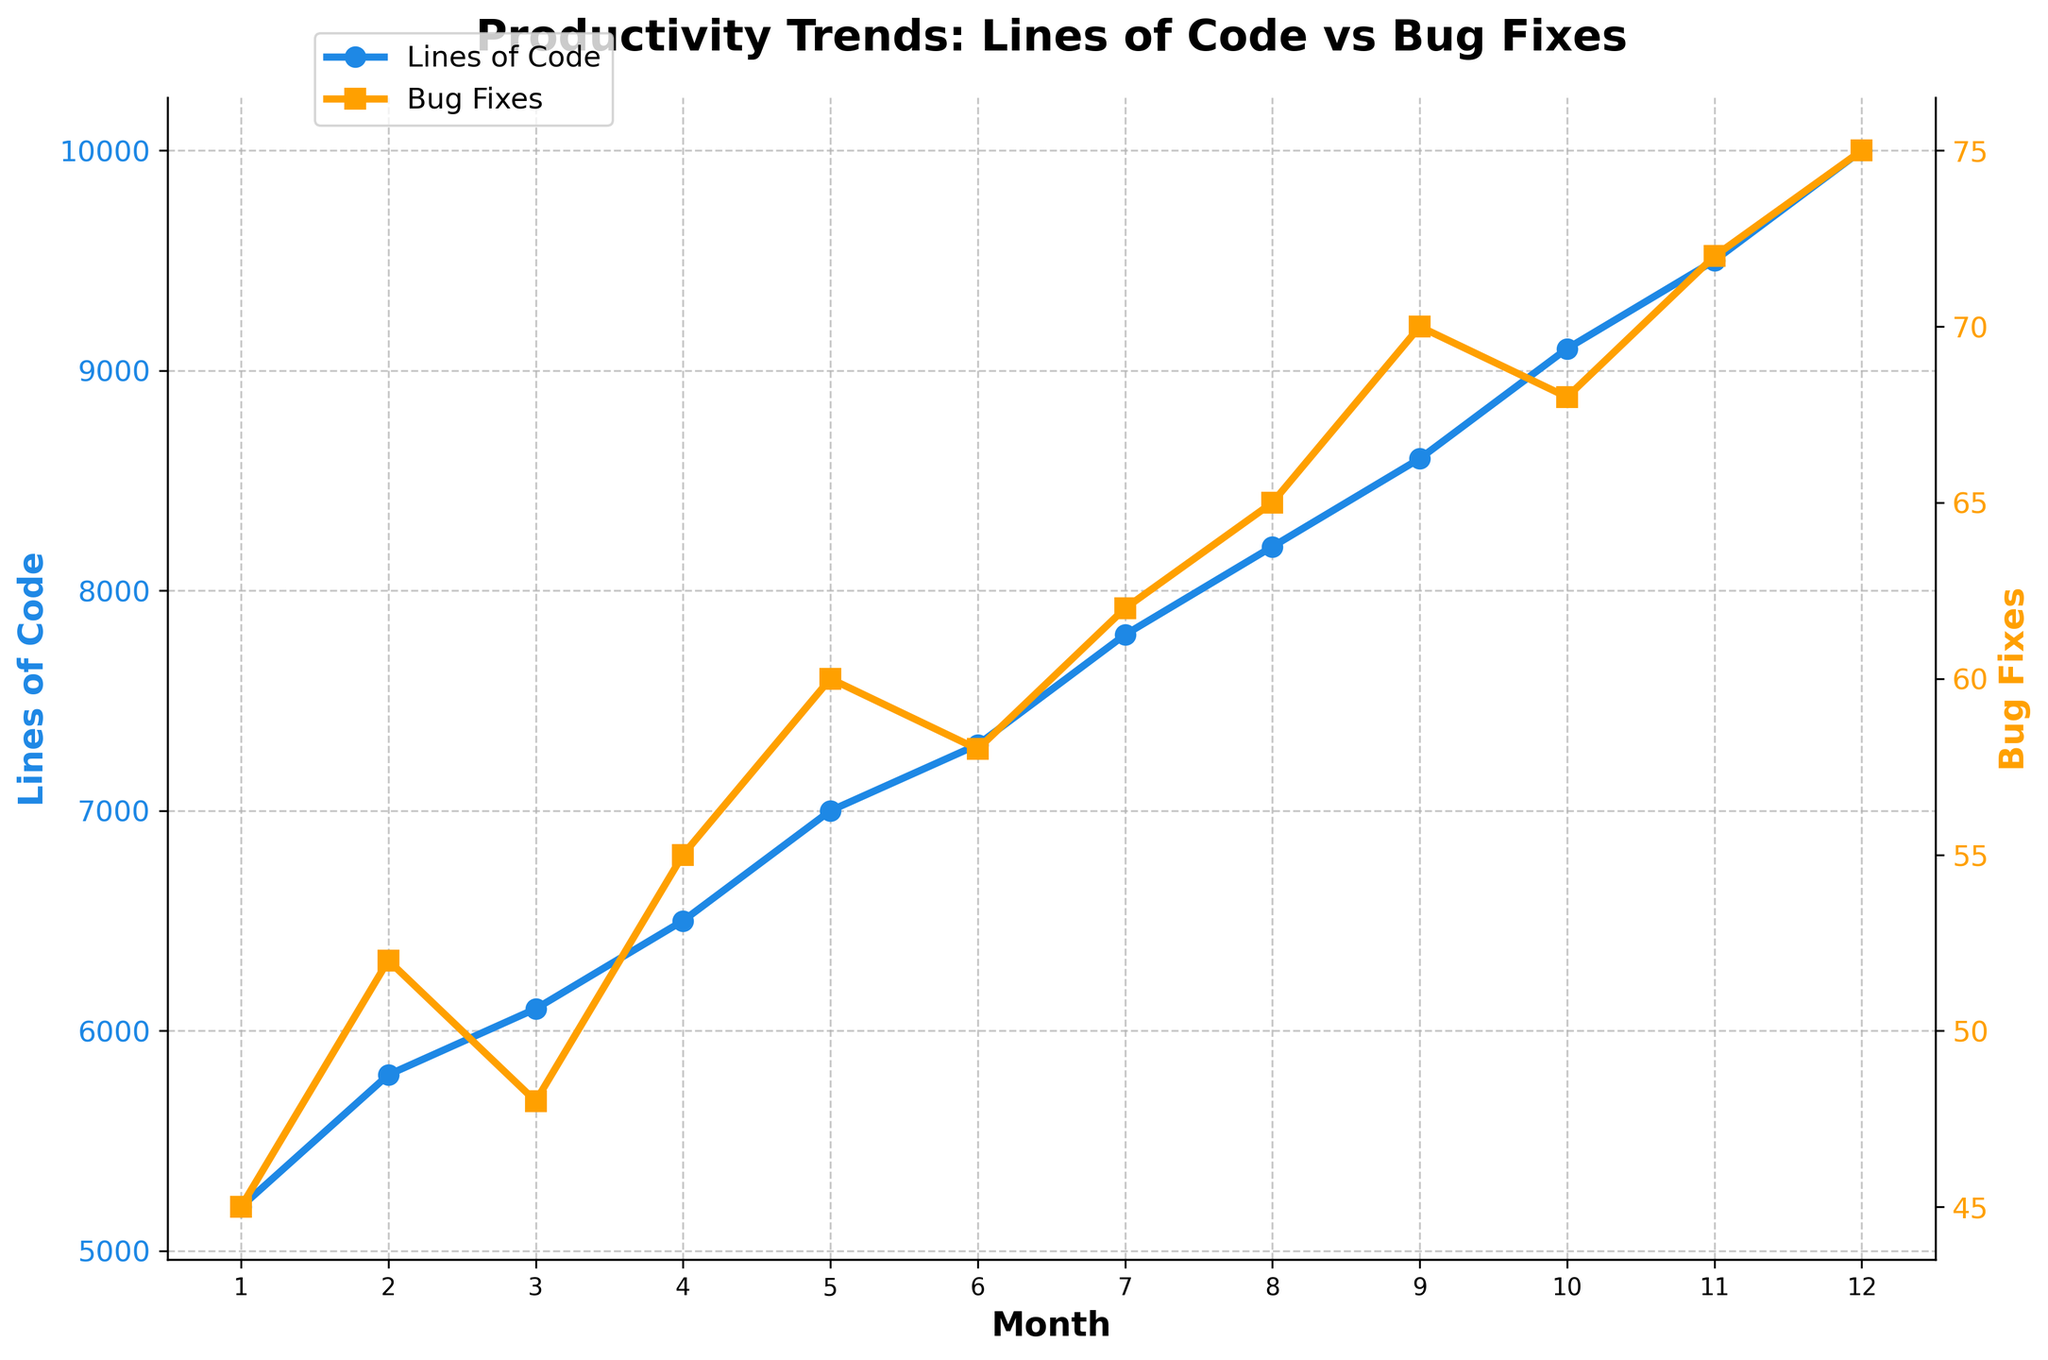What is the overall trend of "Lines of Code" over the 12 months? The "Lines of Code" shows an increasing trend over the 12 months, starting from 5200 in the first month and reaching 10000 by the twelfth month.
Answer: Increasing In which month were the "Lines of Code" and "Bug Fixes" both at their peak? The "Lines of Code" and "Bug Fixes" both peaked in the twelfth month, with values of 10000 and 75, respectively.
Answer: Twelfth month How does the number of "Bug Fixes" in the sixth month compare to that in the third month? The number of "Bug Fixes" in the sixth month is 58, while in the third month, it is 48. Thus, the sixth month has 10 more bug fixes than the third month.
Answer: Sixth month has 10 more bug fixes What is the difference in "Lines of Code" between the first and last month? The "Lines of Code" in the first month is 5200, and in the last month, it is 10000. The difference is 10000 - 5200 = 4800.
Answer: 4800 How do the trends of "Lines of Code" and "Bug Fixes" visually correlate throughout the months? Both the "Lines of Code" and "Bug Fixes" exhibit an upward trend, indicating a positive correlation where an increase in lines of code is associated with an increase in bug fixes.
Answer: Positive correlation Which month shows the highest increase in "Lines of Code" as compared to the previous month? The highest increase in "Lines of Code" occurs between the eleventh and twelfth months, increasing by 500 from 9500 to 10000.
Answer: Between 11th and 12th month What is the average number of "Bug Fixes" over the 12 months? To find the average number of "Bug Fixes," sum all the monthly values and divide by 12: (45 + 52 + 48 + 55 + 60 + 58 + 62 + 65 + 70 + 68 + 72 + 75) / 12 = 690 / 12 = 57.5.
Answer: 57.5 Which month has the smallest difference between "Lines of Code" and "Bug Fixes"? In the first month, the "Lines of Code" is 5200 and "Bug Fixes" is 45, resulting in a difference of 5200 - 45 = 5155. Therefore, you compare each month's differences to find that the smallest difference is in the first month.
Answer: First month How does the number of "Bug Fixes" in the fifth month compare to that in the tenth month? The number of "Bug Fixes" in the fifth month is 60, and in the tenth month is 68; therefore, the tenth month has 8 more bug fixes than the fifth month.
Answer: Tenth month has 8 more bug fixes 